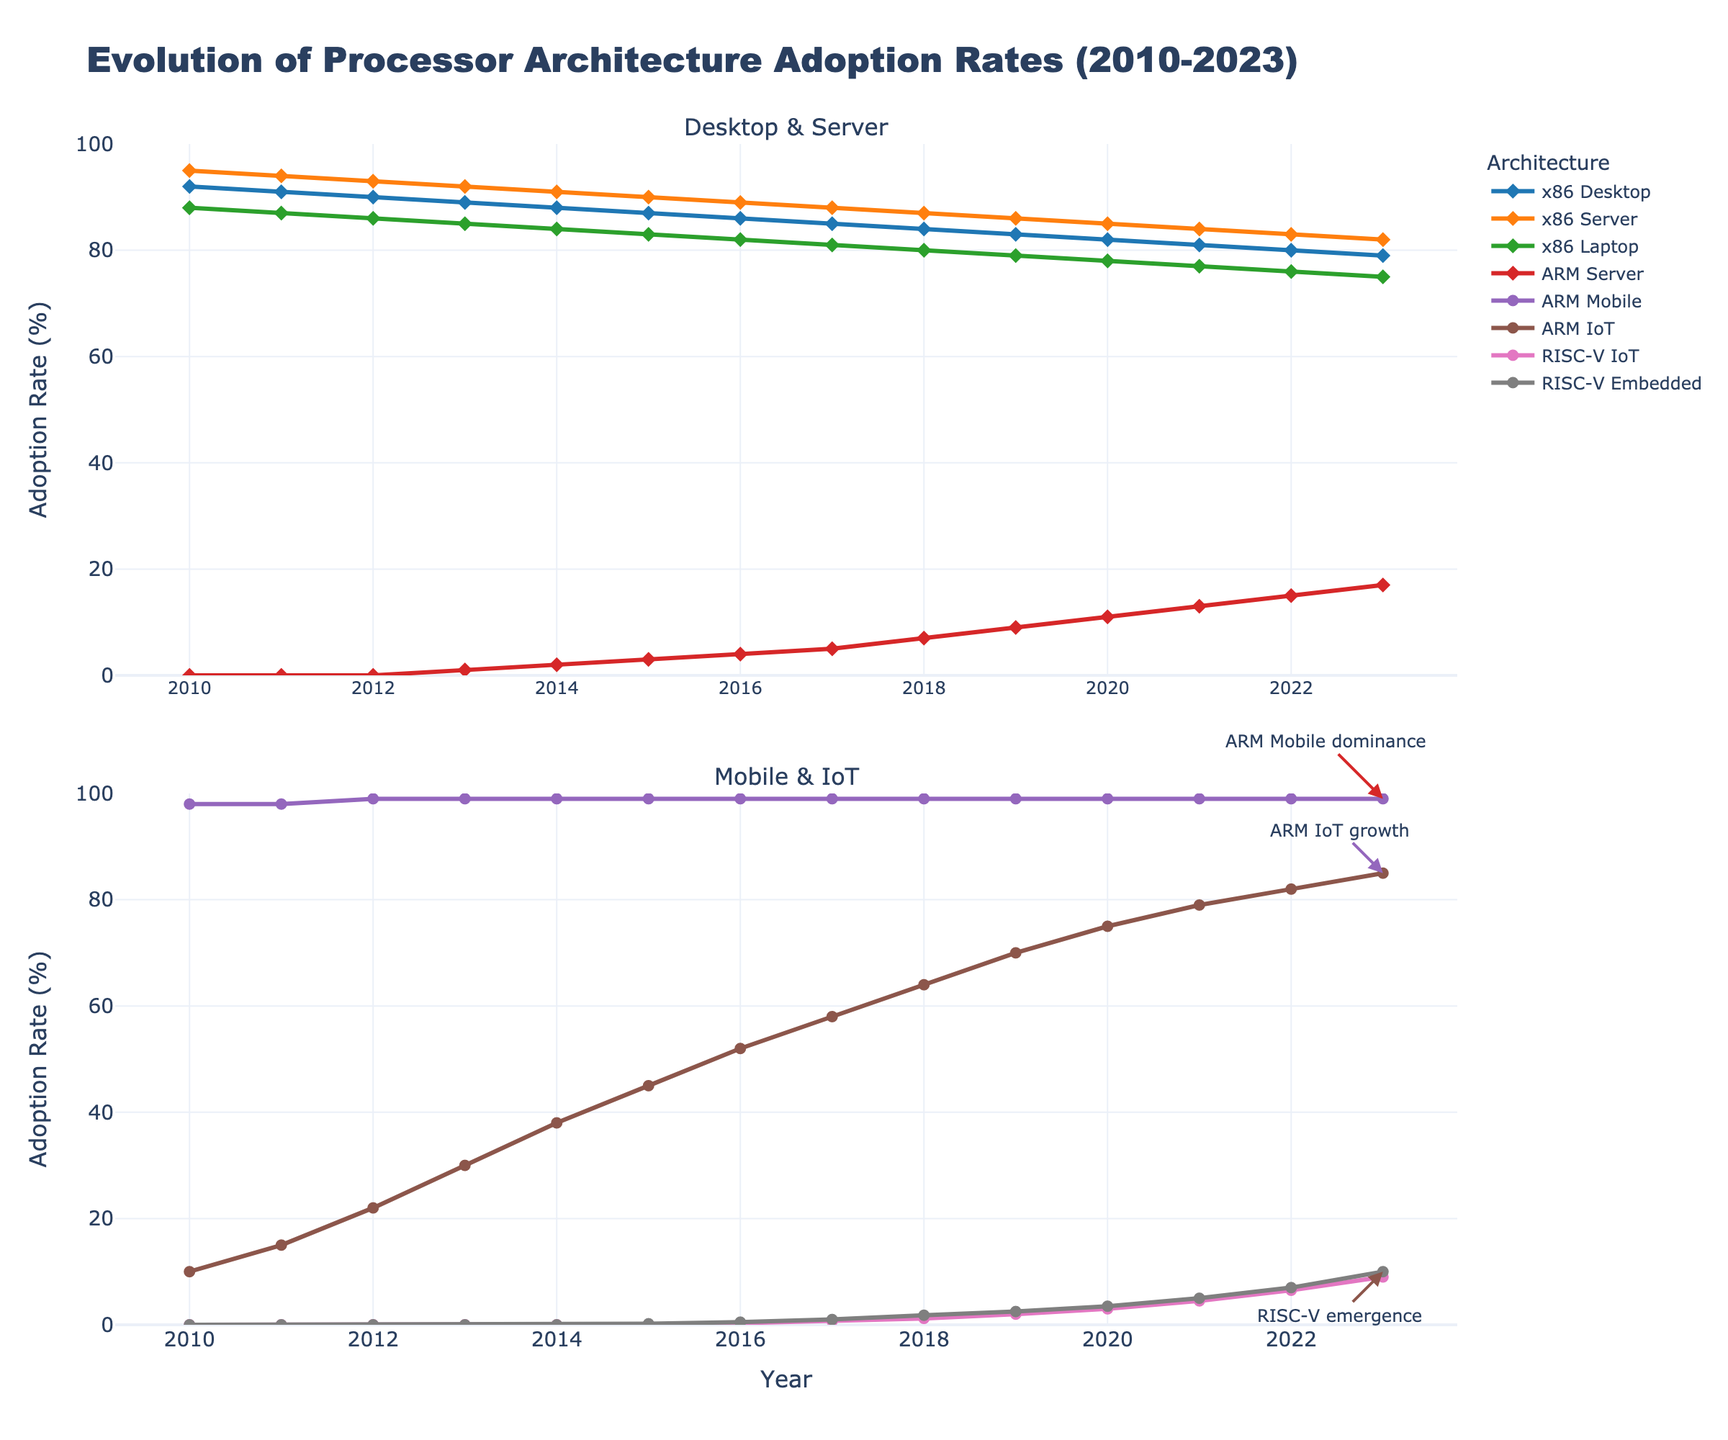what are the adoption rates for ARM Mobile and ARM Server in 2023? Look at the lines representing ARM Mobile and ARM Server for the year 2023 on the x-axis. The ARM Mobile line is at the 99% mark, and the ARM Server line is at the 17% mark.
Answer: ARM Mobile: 99%, ARM Server: 17% Which architecture has shown the most significant increase in the IoT category from 2010 to 2023? The lines for ARM IoT and RISC-V IoT need to be compared from 2010 to 2023. ARM IoT starts at 10% in 2010 and rises to 85% in 2023, while RISC-V IoT starts at 0% and rises to 9%. ARM IoT shows the most significant increase.
Answer: ARM IoT How has the adoption rate for x86 desktops changed from 2010 to 2023? Find the x86 Desktop line and observe its values from 2010 to 2023. It starts at 92% in 2010 and declines to 79% in 2023.
Answer: Decreased from 92% to 79% Between x86 Server and ARM Server, which had a higher adoption rate in 2015? Look at the 2015 data points for x86 Server and ARM Server lines. x86 Server is at 90%, and ARM Server is at 3%.
Answer: x86 Server Which processor architecture has consistently dominated the Mobile category from 2010 to 2023? Examine the ARM Mobile line, which remains extremely high (around 99%) throughout the entire period from 2010 to 2023.
Answer: ARM Mobile Comparing the trends, which architecture shows a rapid increase in the Embedded category? Review the data points for all architectures under the Embedded category. Only the RISC-V Embedded line shows a noticeable upward trend starting from 0% in 2010 to 10% in 2023.
Answer: RISC-V What is the average adoption rate of x86 Server from 2010 to 2023? The x86 Server values from 2010 to 2023 are 95, 94, 93, 92, 91, 90, 89, 88, 87, 86, 85, 84, 83, 82. Sum these up and divide by 14 to get the average. (95+94+93+92+91+90+89+88+87+86+85+84+83+82)/14 ≈ 88.71
Answer: 88.71 How does the adoption rate of ARM IoT compare to RISC-V IoT in 2018? Check the 2018 data for both ARM IoT and RISC-V IoT lines. ARM IoT is at 64%, and RISC-V IoT is at 1.2%.
Answer: ARM IoT is higher What was the adoption rate for all x86 architectures in Server, Laptop, and Desktop categories in 2013? Sum the rates for x86 Server, x86 Laptop, and x86 Desktop in 2013: 92% (Server) + 85% (Laptop) + 89% (Desktop).
Answer: 266% What is the trend in the adoption rate for ARM Server from 2010 to 2023? Look at the ARM Server line across the years. It starts at 0% in 2010 and gradually increases to 17% by 2023.
Answer: Increasing 